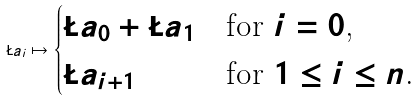<formula> <loc_0><loc_0><loc_500><loc_500>\L a _ { i } \mapsto \begin{cases} \L a _ { 0 } + \L a _ { 1 } & \text {for $i=0$,} \\ \L a _ { i + 1 } & \text {for $1\leq i\leq n$.} \end{cases}</formula> 